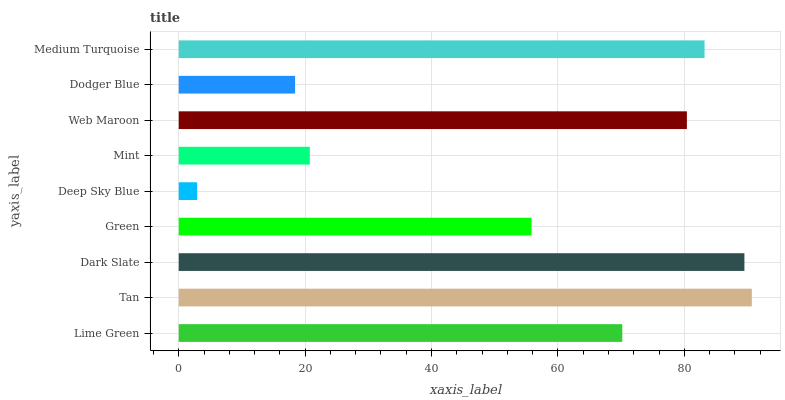Is Deep Sky Blue the minimum?
Answer yes or no. Yes. Is Tan the maximum?
Answer yes or no. Yes. Is Dark Slate the minimum?
Answer yes or no. No. Is Dark Slate the maximum?
Answer yes or no. No. Is Tan greater than Dark Slate?
Answer yes or no. Yes. Is Dark Slate less than Tan?
Answer yes or no. Yes. Is Dark Slate greater than Tan?
Answer yes or no. No. Is Tan less than Dark Slate?
Answer yes or no. No. Is Lime Green the high median?
Answer yes or no. Yes. Is Lime Green the low median?
Answer yes or no. Yes. Is Mint the high median?
Answer yes or no. No. Is Dodger Blue the low median?
Answer yes or no. No. 